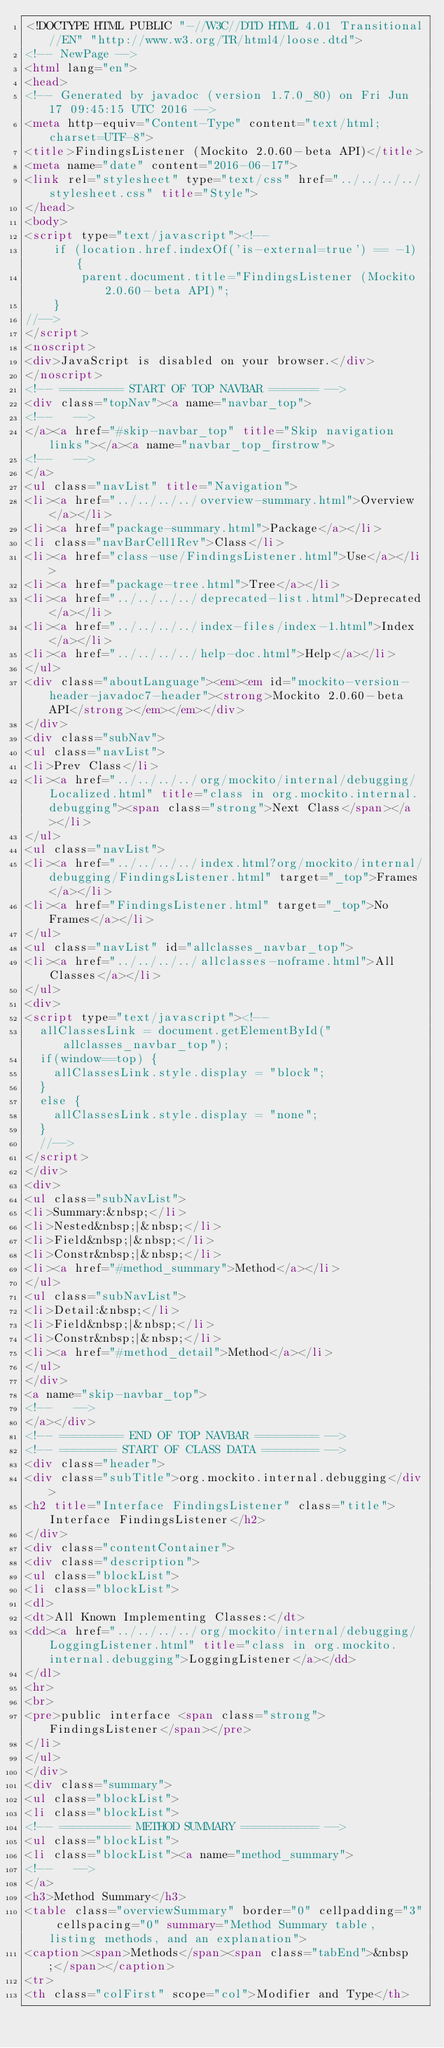Convert code to text. <code><loc_0><loc_0><loc_500><loc_500><_HTML_><!DOCTYPE HTML PUBLIC "-//W3C//DTD HTML 4.01 Transitional//EN" "http://www.w3.org/TR/html4/loose.dtd">
<!-- NewPage -->
<html lang="en">
<head>
<!-- Generated by javadoc (version 1.7.0_80) on Fri Jun 17 09:45:15 UTC 2016 -->
<meta http-equiv="Content-Type" content="text/html; charset=UTF-8">
<title>FindingsListener (Mockito 2.0.60-beta API)</title>
<meta name="date" content="2016-06-17">
<link rel="stylesheet" type="text/css" href="../../../../stylesheet.css" title="Style">
</head>
<body>
<script type="text/javascript"><!--
    if (location.href.indexOf('is-external=true') == -1) {
        parent.document.title="FindingsListener (Mockito 2.0.60-beta API)";
    }
//-->
</script>
<noscript>
<div>JavaScript is disabled on your browser.</div>
</noscript>
<!-- ========= START OF TOP NAVBAR ======= -->
<div class="topNav"><a name="navbar_top">
<!--   -->
</a><a href="#skip-navbar_top" title="Skip navigation links"></a><a name="navbar_top_firstrow">
<!--   -->
</a>
<ul class="navList" title="Navigation">
<li><a href="../../../../overview-summary.html">Overview</a></li>
<li><a href="package-summary.html">Package</a></li>
<li class="navBarCell1Rev">Class</li>
<li><a href="class-use/FindingsListener.html">Use</a></li>
<li><a href="package-tree.html">Tree</a></li>
<li><a href="../../../../deprecated-list.html">Deprecated</a></li>
<li><a href="../../../../index-files/index-1.html">Index</a></li>
<li><a href="../../../../help-doc.html">Help</a></li>
</ul>
<div class="aboutLanguage"><em><em id="mockito-version-header-javadoc7-header"><strong>Mockito 2.0.60-beta API</strong></em></em></div>
</div>
<div class="subNav">
<ul class="navList">
<li>Prev Class</li>
<li><a href="../../../../org/mockito/internal/debugging/Localized.html" title="class in org.mockito.internal.debugging"><span class="strong">Next Class</span></a></li>
</ul>
<ul class="navList">
<li><a href="../../../../index.html?org/mockito/internal/debugging/FindingsListener.html" target="_top">Frames</a></li>
<li><a href="FindingsListener.html" target="_top">No Frames</a></li>
</ul>
<ul class="navList" id="allclasses_navbar_top">
<li><a href="../../../../allclasses-noframe.html">All Classes</a></li>
</ul>
<div>
<script type="text/javascript"><!--
  allClassesLink = document.getElementById("allclasses_navbar_top");
  if(window==top) {
    allClassesLink.style.display = "block";
  }
  else {
    allClassesLink.style.display = "none";
  }
  //-->
</script>
</div>
<div>
<ul class="subNavList">
<li>Summary:&nbsp;</li>
<li>Nested&nbsp;|&nbsp;</li>
<li>Field&nbsp;|&nbsp;</li>
<li>Constr&nbsp;|&nbsp;</li>
<li><a href="#method_summary">Method</a></li>
</ul>
<ul class="subNavList">
<li>Detail:&nbsp;</li>
<li>Field&nbsp;|&nbsp;</li>
<li>Constr&nbsp;|&nbsp;</li>
<li><a href="#method_detail">Method</a></li>
</ul>
</div>
<a name="skip-navbar_top">
<!--   -->
</a></div>
<!-- ========= END OF TOP NAVBAR ========= -->
<!-- ======== START OF CLASS DATA ======== -->
<div class="header">
<div class="subTitle">org.mockito.internal.debugging</div>
<h2 title="Interface FindingsListener" class="title">Interface FindingsListener</h2>
</div>
<div class="contentContainer">
<div class="description">
<ul class="blockList">
<li class="blockList">
<dl>
<dt>All Known Implementing Classes:</dt>
<dd><a href="../../../../org/mockito/internal/debugging/LoggingListener.html" title="class in org.mockito.internal.debugging">LoggingListener</a></dd>
</dl>
<hr>
<br>
<pre>public interface <span class="strong">FindingsListener</span></pre>
</li>
</ul>
</div>
<div class="summary">
<ul class="blockList">
<li class="blockList">
<!-- ========== METHOD SUMMARY =========== -->
<ul class="blockList">
<li class="blockList"><a name="method_summary">
<!--   -->
</a>
<h3>Method Summary</h3>
<table class="overviewSummary" border="0" cellpadding="3" cellspacing="0" summary="Method Summary table, listing methods, and an explanation">
<caption><span>Methods</span><span class="tabEnd">&nbsp;</span></caption>
<tr>
<th class="colFirst" scope="col">Modifier and Type</th></code> 